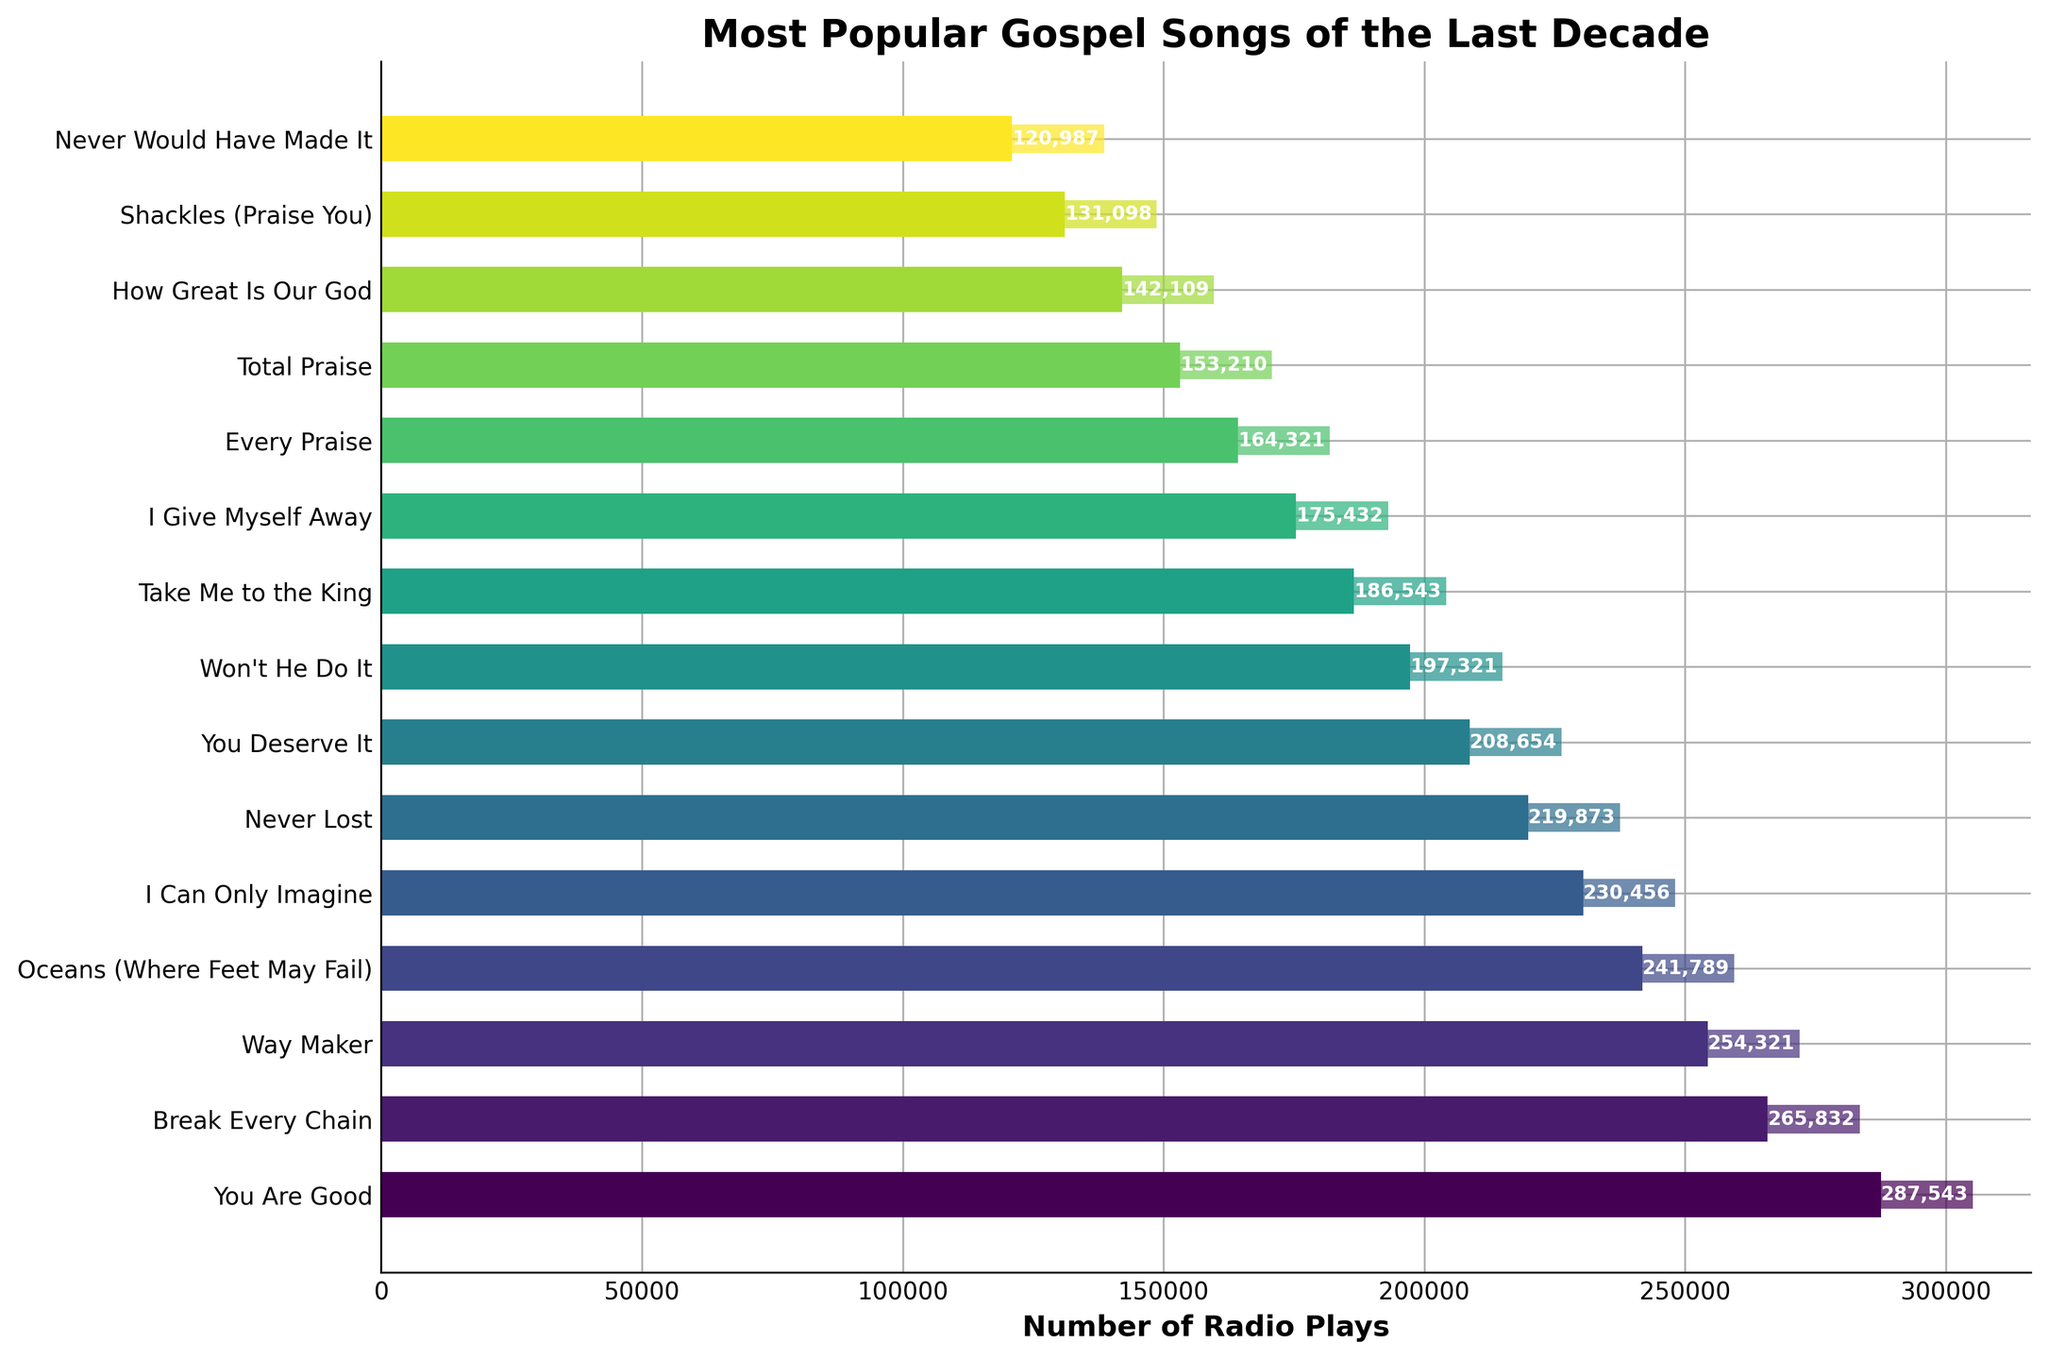Which song has the highest number of radio plays? By looking at the length of the bars, the bar for "You Are Good" by Israel & New Breed is the longest, indicating the highest number of radio plays.
Answer: "You Are Good" by Israel & New Breed Which song has fewer radio plays: "Break Every Chain" or "Way Maker"? The bar for "Way Maker" by Sinach is shorter than the bar for "Break Every Chain" by Tasha Cobbs Leonard, indicating it has fewer radio plays.
Answer: "Way Maker" What is the total number of radio plays for the top three songs? The numbers for the top three songs are 287543, 265832, and 254321. Adding these together: 287543 + 265832 + 254321 = 807696.
Answer: 807696 Which songs have radio plays between 200,000 and 250,000? The bars that fall within this range are for "Way Maker" by Sinach, "Oceans (Where Feet May Fail)" by Hillsong UNITED, and "I Can Only Imagine" by MercyMe.
Answer: "Way Maker," "Oceans (Where Feet May Fail)," "I Can Only Imagine" How many songs have radio plays above 200,000? Count the bars that extend beyond the 200,000 mark: "You Are Good," "Break Every Chain," "Way Maker," "Oceans (Where Feet May Fail)," and "I Can Only Imagine." There are 5 songs in total.
Answer: 5 What is the difference in radio plays between "You Deserve It" and "Won't He Do It"? The radio plays for "You Deserve It" are 208654, and for "Won't He Do It," they are 197321. The difference is 208654 - 197321 = 11333.
Answer: 11333 Which song has the second highest number of radio plays? The bar for "Break Every Chain" by Tasha Cobbs Leonard is the second longest, indicating it has the second highest number of radio plays.
Answer: "Break Every Chain" by Tasha Cobbs Leonard Which songs have fewer than 150,000 radio plays? The bars that are shorter than the 150,000 mark are for "Shackles (Praise You)" by Mary Mary and "Never Would Have Made It" by Marvin Sapp.
Answer: "Shackles (Praise You)," "Never Would Have Made It" What is the average number of radio plays for "Total Praise," "How Great Is Our God," and "Shackles (Praise You)"? The radio plays for these songs are 153210, 142109, and 131098. The average is (153210 + 142109 + 131098) / 3 = 142139.
Answer: 142139 